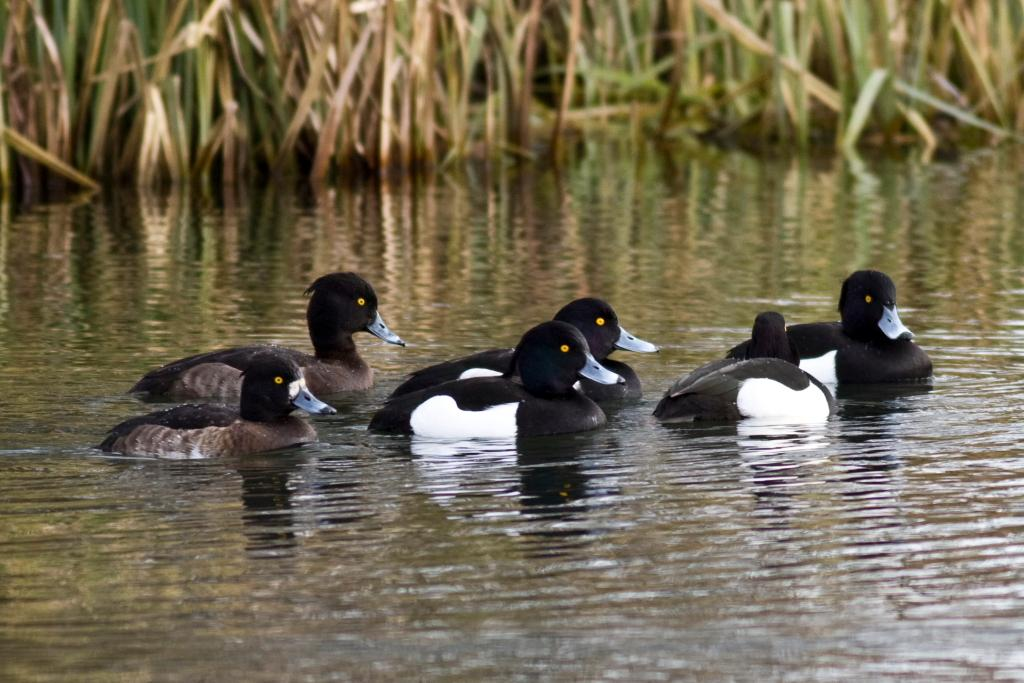What type of animals can be seen in the image? There are ducks in the water in the image. What else can be seen in the image besides the ducks? There are plants and water visible in the image. What is the relationship between the water and the plants and ducks? The plants and ducks are reflected on the water's surface. What type of cakes can be seen in the image? There are no cakes present in the image; it features ducks in the water with plants and reflections. 